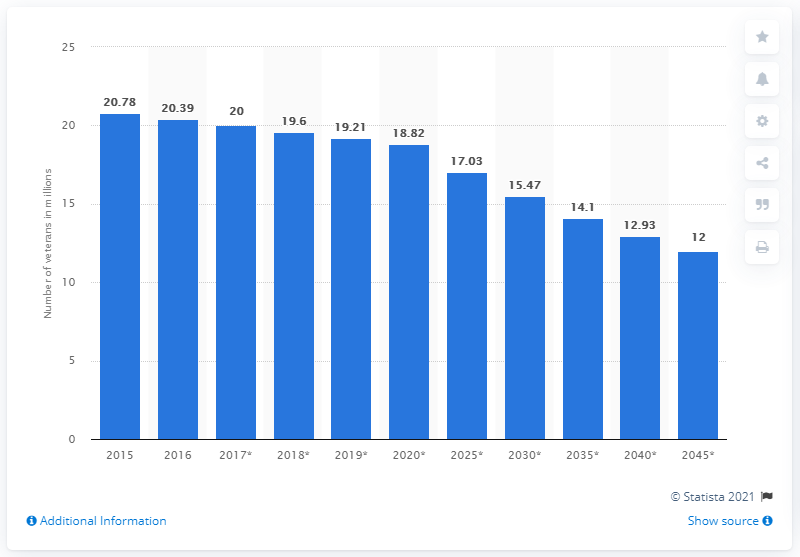Identify some key points in this picture. It is projected that in 2045, there will be approximately 12 veterans living in the United States. In 2016, there were approximately 20.39 million veterans living in the United States. 